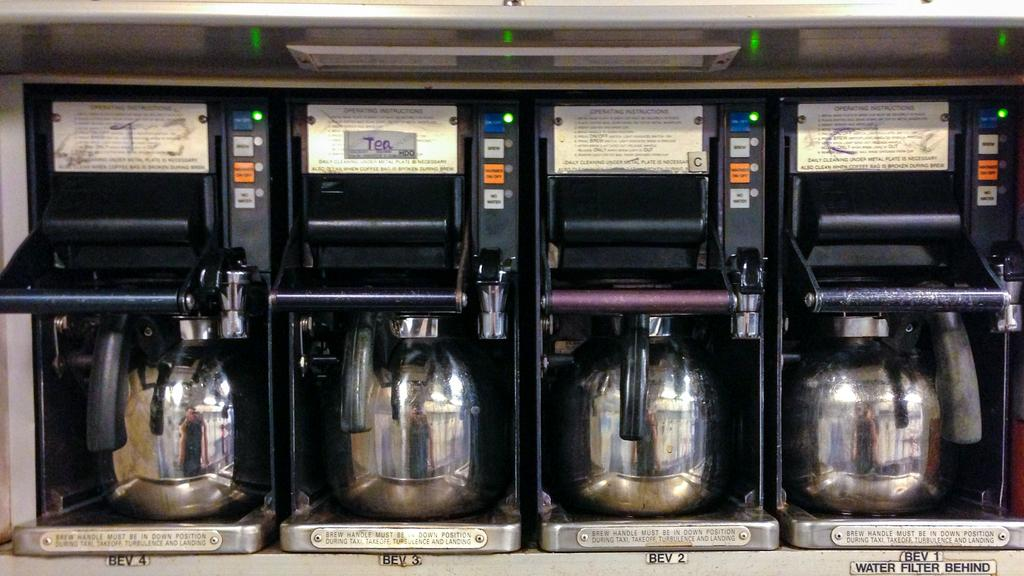<image>
Write a terse but informative summary of the picture. Four coffee machines that say the brew handle must be in down position. 